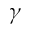Convert formula to latex. <formula><loc_0><loc_0><loc_500><loc_500>\gamma</formula> 